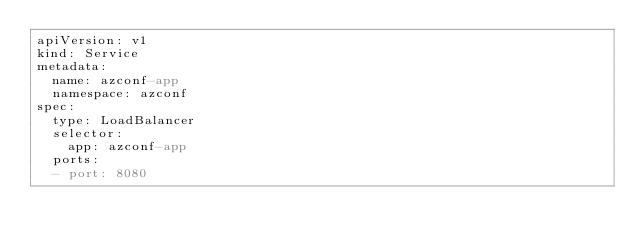Convert code to text. <code><loc_0><loc_0><loc_500><loc_500><_YAML_>apiVersion: v1
kind: Service
metadata:
  name: azconf-app
  namespace: azconf
spec:
  type: LoadBalancer
  selector:
    app: azconf-app
  ports:
  - port: 8080
</code> 